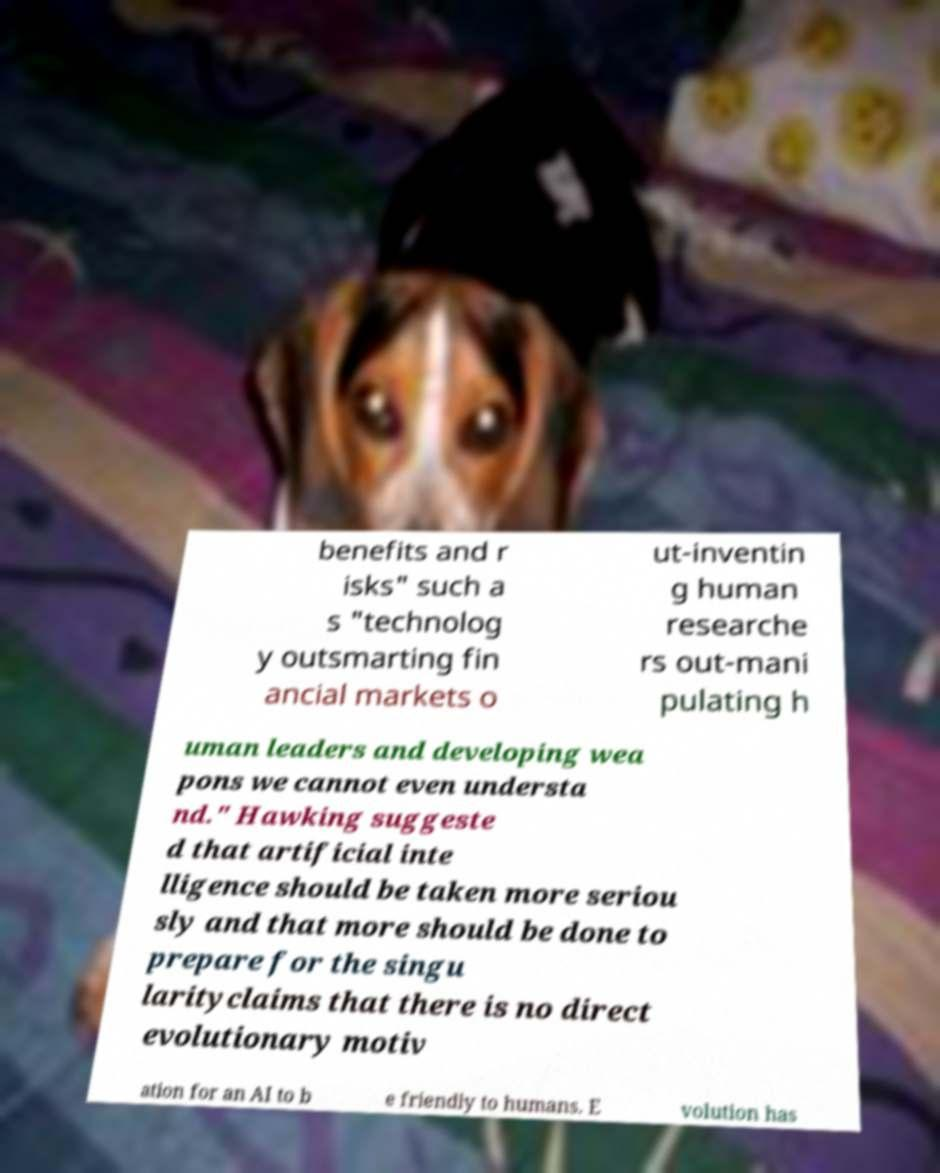For documentation purposes, I need the text within this image transcribed. Could you provide that? benefits and r isks" such a s "technolog y outsmarting fin ancial markets o ut-inventin g human researche rs out-mani pulating h uman leaders and developing wea pons we cannot even understa nd." Hawking suggeste d that artificial inte lligence should be taken more seriou sly and that more should be done to prepare for the singu larityclaims that there is no direct evolutionary motiv ation for an AI to b e friendly to humans. E volution has 